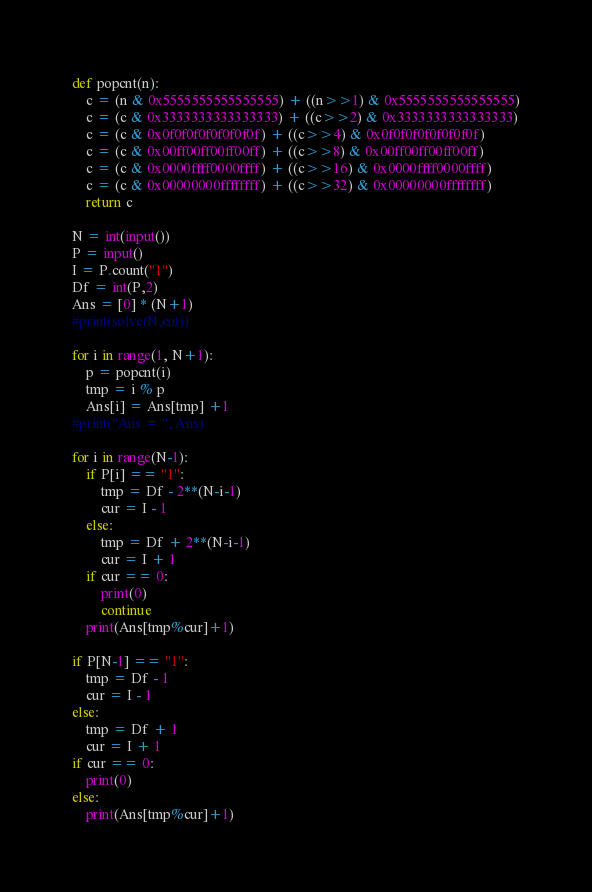Convert code to text. <code><loc_0><loc_0><loc_500><loc_500><_Python_>def popcnt(n):
    c = (n & 0x5555555555555555) + ((n>>1) & 0x5555555555555555)
    c = (c & 0x3333333333333333) + ((c>>2) & 0x3333333333333333)
    c = (c & 0x0f0f0f0f0f0f0f0f) + ((c>>4) & 0x0f0f0f0f0f0f0f0f)
    c = (c & 0x00ff00ff00ff00ff) + ((c>>8) & 0x00ff00ff00ff00ff)
    c = (c & 0x0000ffff0000ffff) + ((c>>16) & 0x0000ffff0000ffff)
    c = (c & 0x00000000ffffffff) + ((c>>32) & 0x00000000ffffffff)
    return c
    
N = int(input())
P = input()
I = P.count("1")
Df = int(P,2)
Ans = [0] * (N+1)
#print(solve(N,cnt))

for i in range(1, N+1):
    p = popcnt(i)
    tmp = i % p
    Ans[i] = Ans[tmp] +1 
#print("Ans = ", Ans)

for i in range(N-1):
    if P[i] == "1":
        tmp = Df - 2**(N-i-1)
        cur = I - 1
    else:
        tmp = Df + 2**(N-i-1)
        cur = I + 1 
    if cur == 0:
        print(0)
        continue
    print(Ans[tmp%cur]+1)

if P[N-1] == "1":
    tmp = Df - 1
    cur = I - 1
else:
    tmp = Df + 1
    cur = I + 1
if cur == 0:
    print(0)
else:
    print(Ans[tmp%cur]+1)</code> 